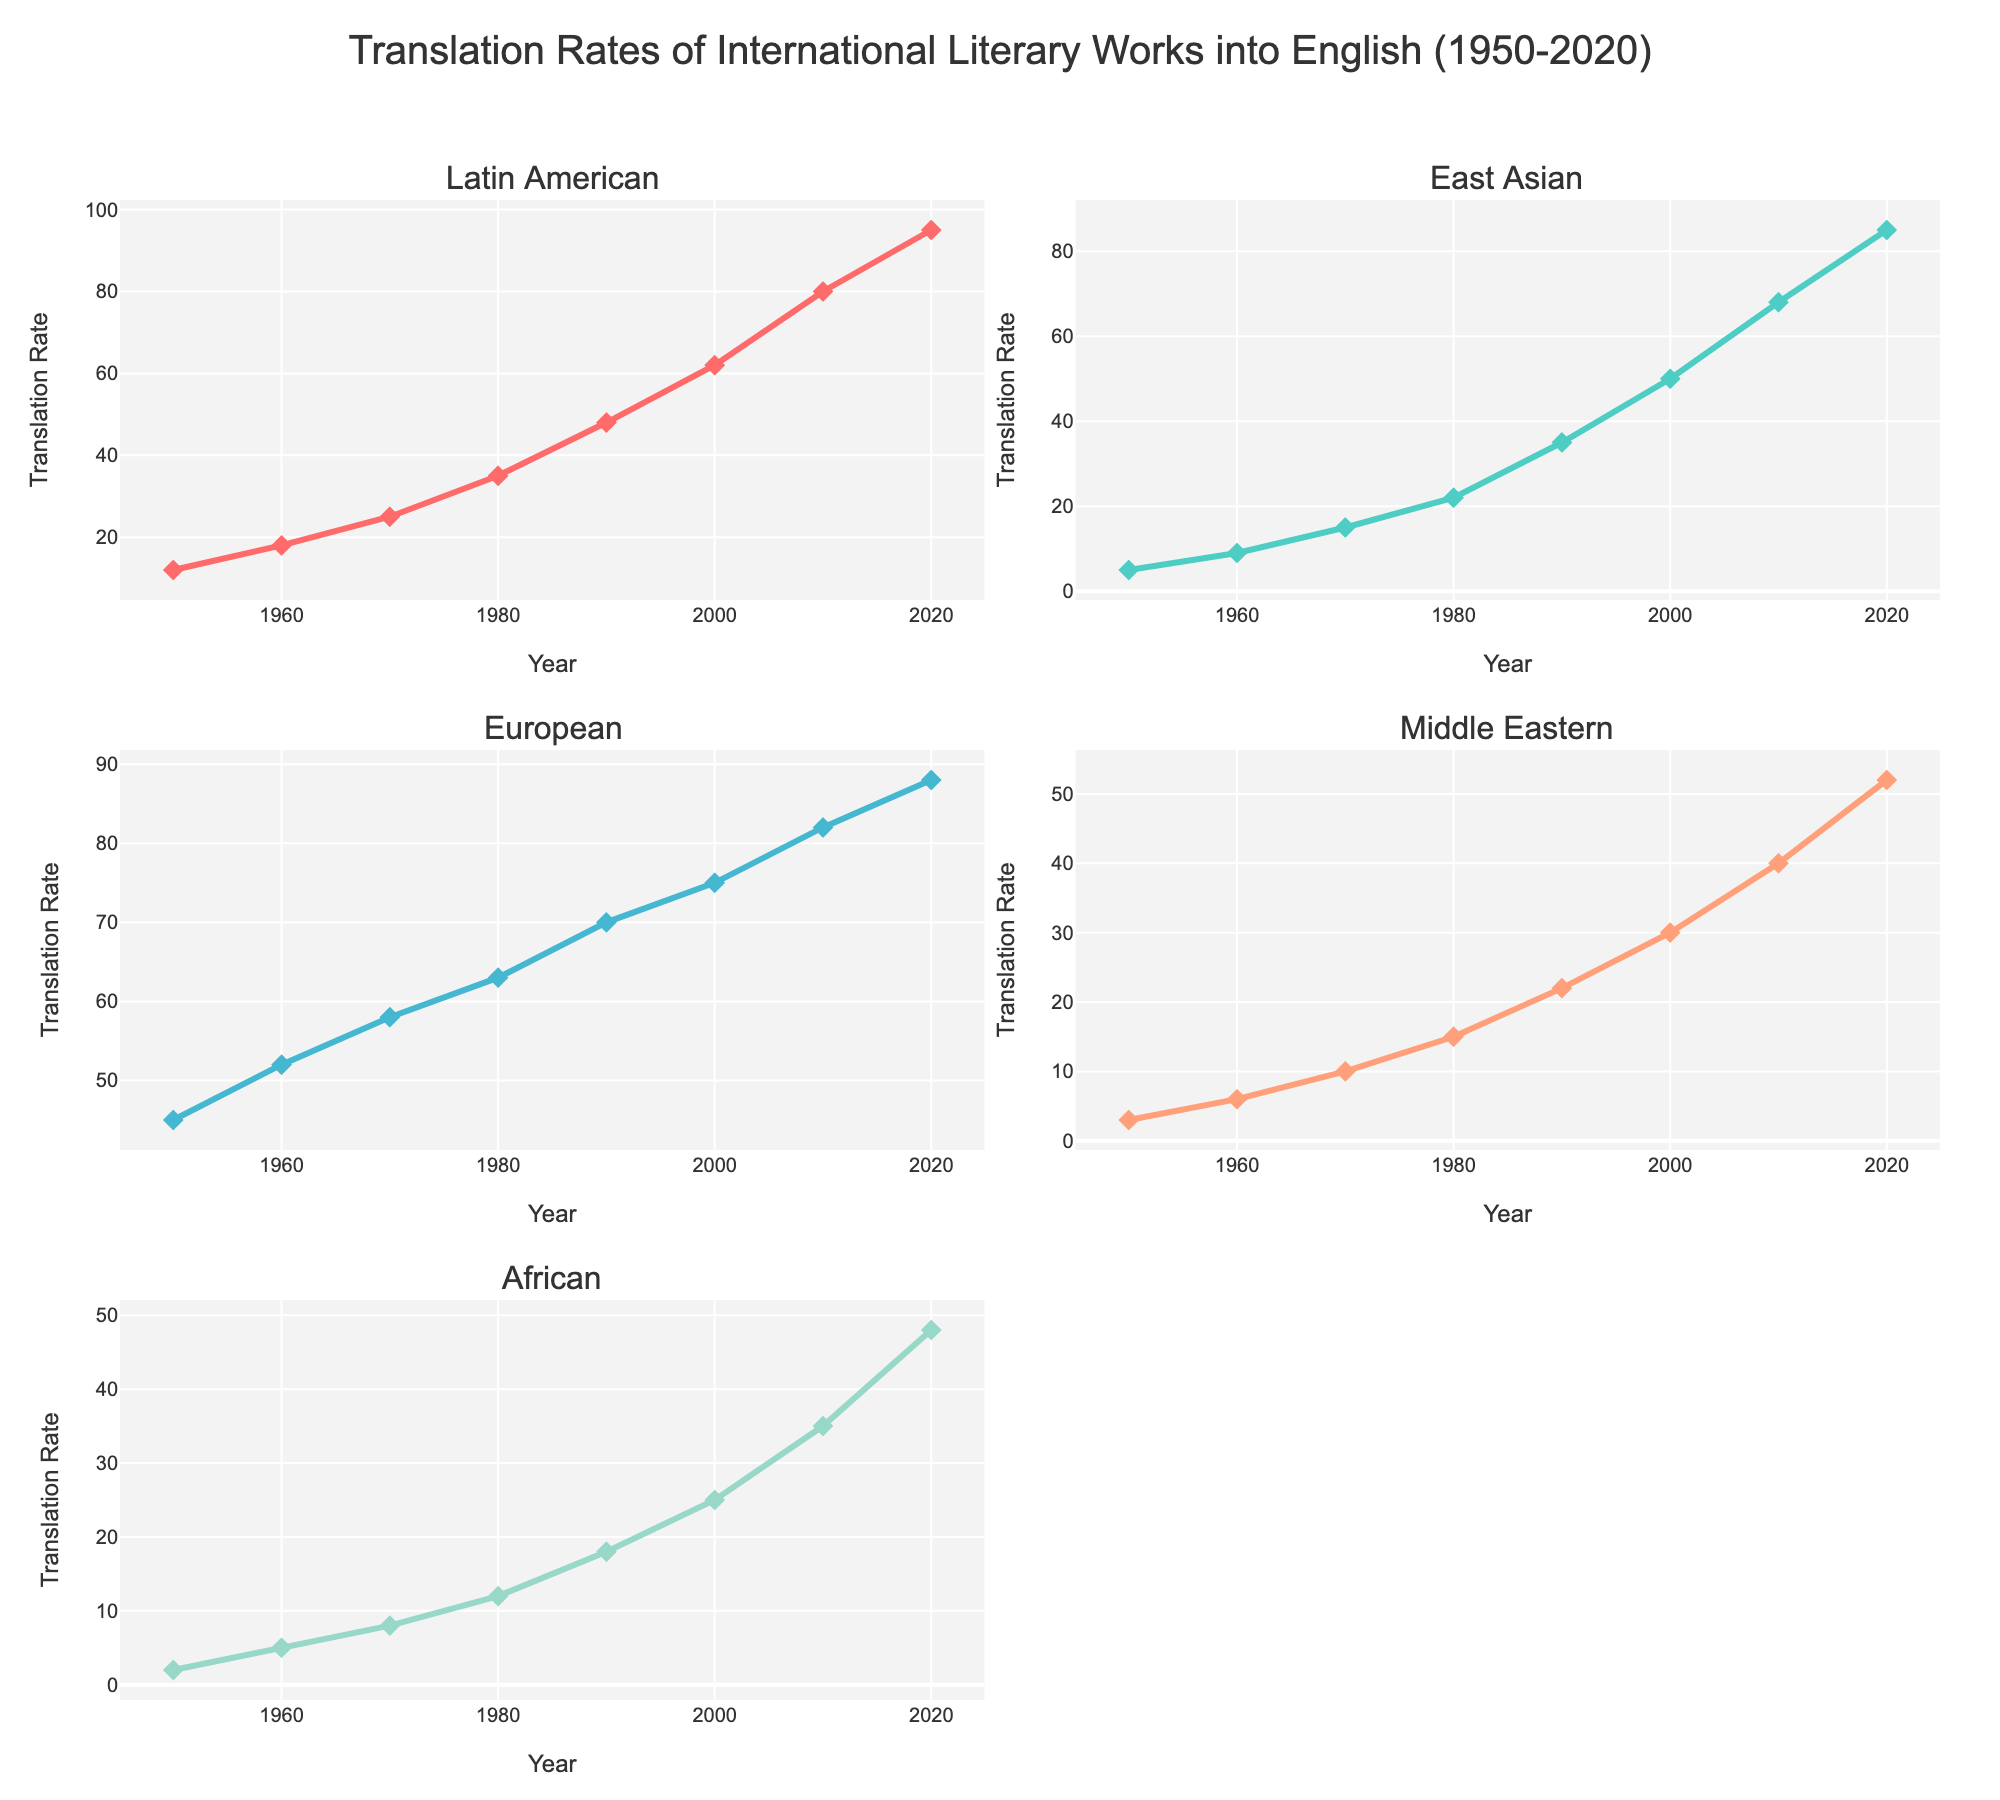Which region had the highest translation rate in 1980? Check the subplot for the year 1980 and identify the highest value among all regions. The subplot for Europe shows a translation rate of 63, which is the highest for that year.
Answer: European Between 1950 to 2020, how many times did the translation rate for Latin American works surpass 50? Look at the subplot for Latin America and count the years where the translation rate is above 50. The years are 1990, 2000, 2010, and 2020.
Answer: 4 Compare the growth rate of translations between African and East Asian literary works from 1950 to 1960. Which region had a larger increase? Calculate the increase for both regions. African grew from 2 to 5 (3 units) and East Asian from 5 to 9 (4 units).
Answer: East Asian What is the translation rate trend for Middle Eastern works, and how does it compare to African works from 2000 to 2020? Check the Middle Eastern subplot from 2000 to 2020 (30 to 52) and African subplot from 2000 to 2020 (25 to 48). Both show an increasing trend, but Middle Eastern has a larger increase.
Answer: Both increase, Middle Eastern larger What's the difference in the translation rate of European literary works between 1950 and 2020? Identify the translation rates for European works in 1950 (45) and 2020 (88) and subtract the former from the latter. The difference is 88 - 45 = 43.
Answer: 43 Between 2010 and 2020, which region showed the smallest increase in translation rates? Calculate the difference for each region between 2010 and 2020, then identify the smallest one. 
Latin American: 95 - 80 = 15
East Asian: 85 - 68 = 17
European: 88 - 82 = 6
Middle Eastern: 52 - 40 = 12
African: 48 - 35 = 13 
The smallest increase is 6 by European works.
Answer: European What is the average translation rate for East Asian works between 1950 and 2020? Add all the translation rates for the East Asian subplot (5+9+15+22+35+50+68+85) and divide by the number of data points (8). The sum is 289 and the average is 289/8 = 36.125.
Answer: 36.125 How does the trend in translation rates for Middle Eastern works in the 1990s compare to the 2010s? Compare the translation rates in the subplot for Middle Eastern works from 1990 (22) to 2000 (30) and 2010 (40) to 2020 (52). Both decades show an increasing trend, with rates rising from 22 to 30 and then from 40 to 52.
Answer: Both rising Which decade saw the largest increase in translation rates for Latin American works? Compare the increase for each decade in the Latin American subplot. The largest increase is from 2010 (80) to 2020 (95), which is 15 units.
Answer: 2010 to 2020 Across all regions, which year saw the highest translation rate for any single region? Look at all subplots and identify the highest single value across all regions. The highest value is 95 for Latin American works in 2020.
Answer: 2020 